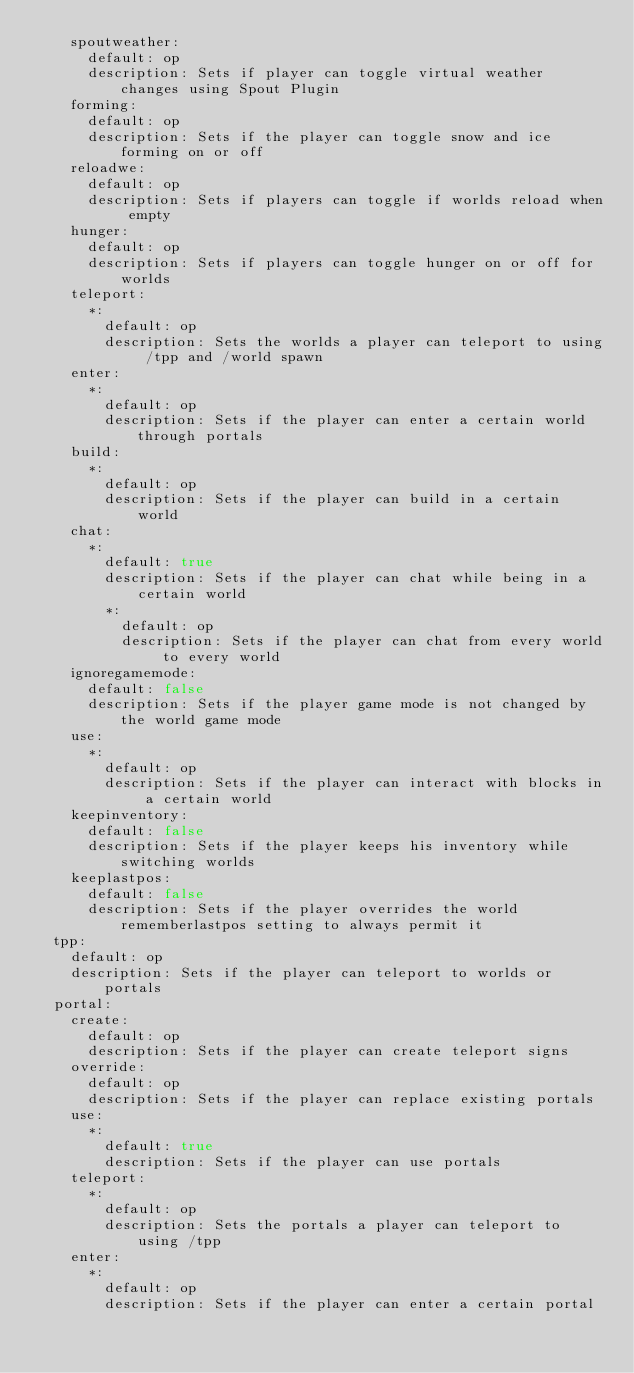Convert code to text. <code><loc_0><loc_0><loc_500><loc_500><_YAML_>    spoutweather:
      default: op
      description: Sets if player can toggle virtual weather changes using Spout Plugin
    forming:
      default: op
      description: Sets if the player can toggle snow and ice forming on or off
    reloadwe:
      default: op
      description: Sets if players can toggle if worlds reload when empty
    hunger:
      default: op
      description: Sets if players can toggle hunger on or off for worlds
    teleport:
      *:
        default: op
        description: Sets the worlds a player can teleport to using /tpp and /world spawn
    enter:
      *:
        default: op
        description: Sets if the player can enter a certain world through portals
    build:
      *:
        default: op
        description: Sets if the player can build in a certain world
    chat:
      *:
        default: true
        description: Sets if the player can chat while being in a certain world
        *:
          default: op
          description: Sets if the player can chat from every world to every world
    ignoregamemode:
      default: false
      description: Sets if the player game mode is not changed by the world game mode
    use:
      *:
        default: op
        description: Sets if the player can interact with blocks in a certain world
    keepinventory:
      default: false
      description: Sets if the player keeps his inventory while switching worlds
    keeplastpos:
      default: false
      description: Sets if the player overrides the world rememberlastpos setting to always permit it
  tpp:
    default: op
    description: Sets if the player can teleport to worlds or portals
  portal:
    create:
      default: op
      description: Sets if the player can create teleport signs
    override:
      default: op
      description: Sets if the player can replace existing portals
    use:
      *:
        default: true
        description: Sets if the player can use portals
    teleport:
      *:
        default: op
        description: Sets the portals a player can teleport to using /tpp
    enter:
      *:
        default: op
        description: Sets if the player can enter a certain portal

</code> 